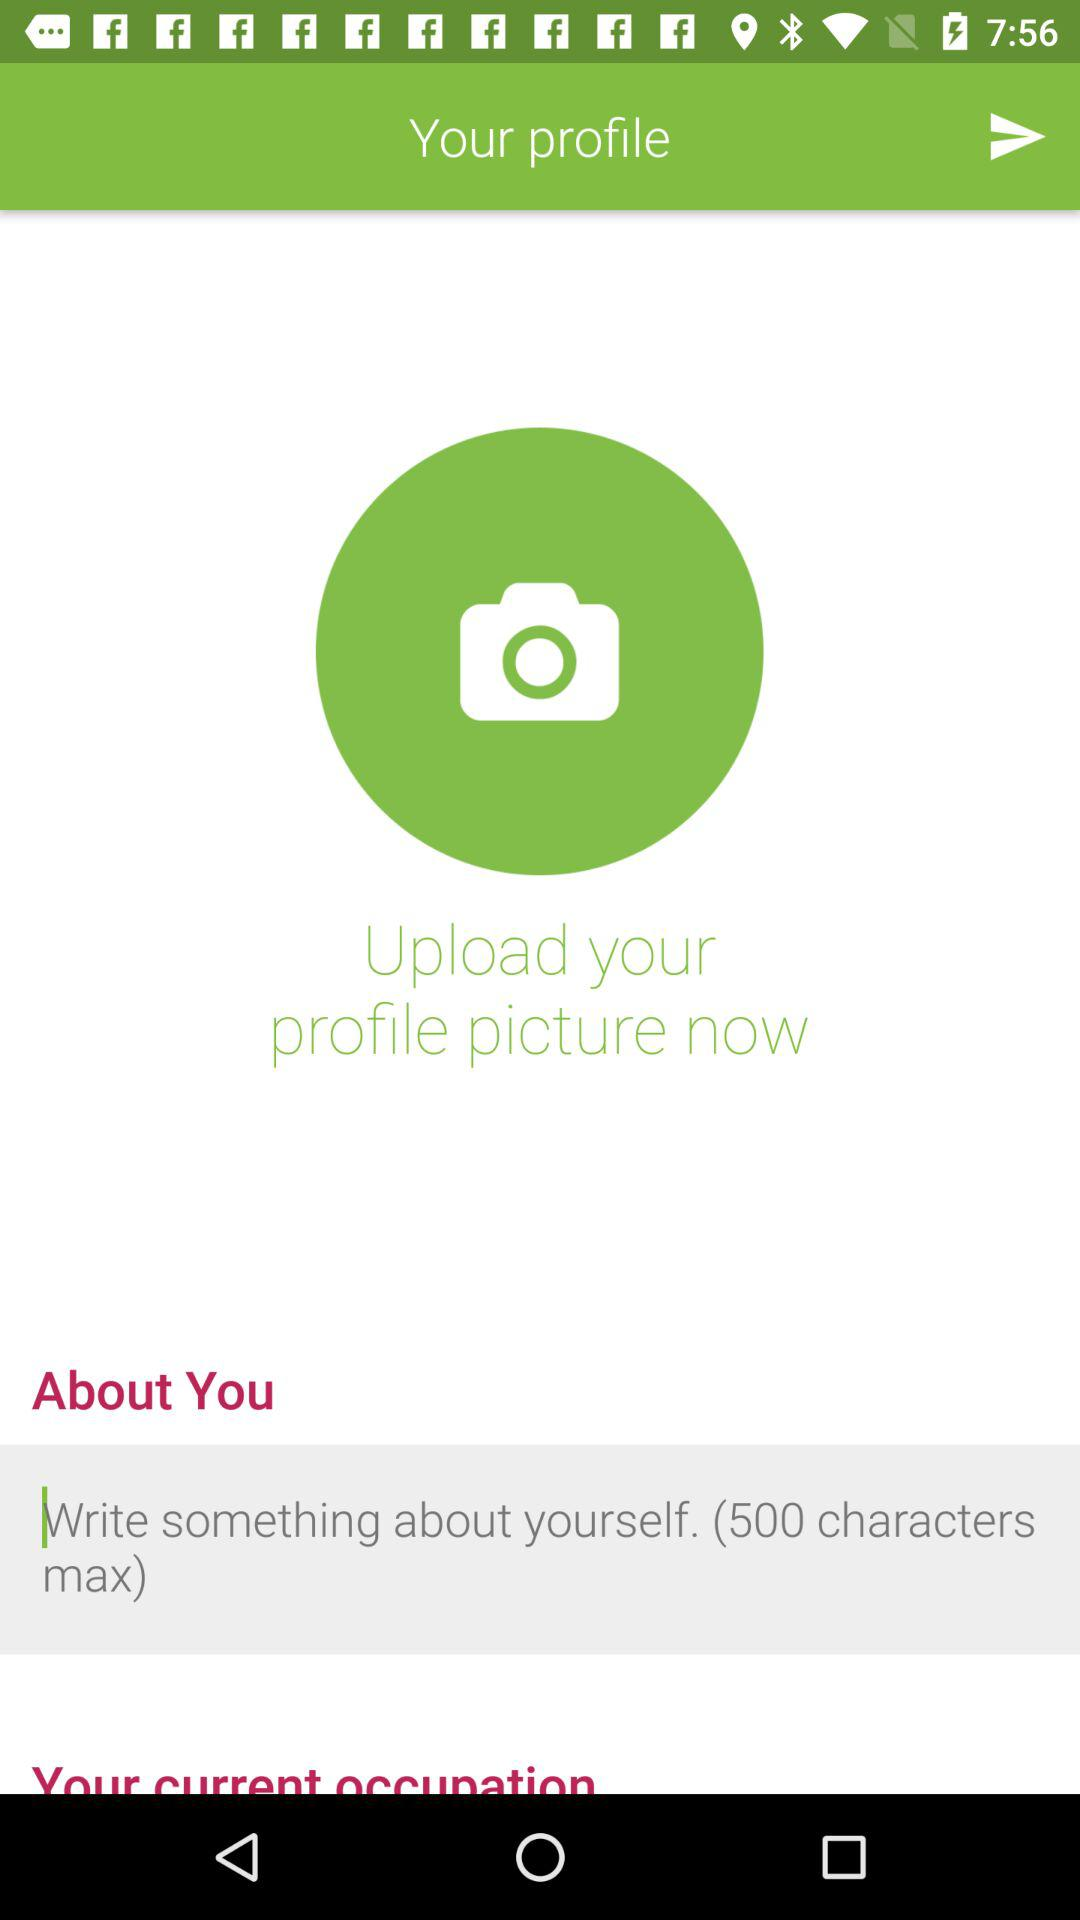How many maximum characters can be used in the "About You" section? The maximum number of characters that can be used is 500. 